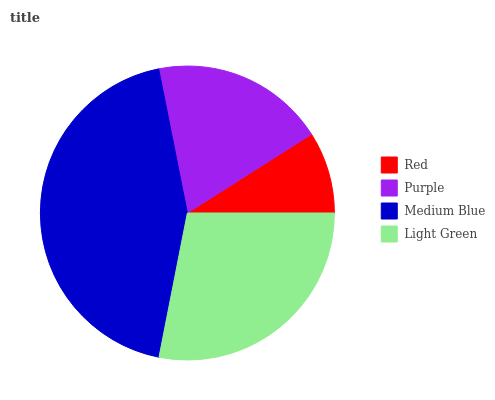Is Red the minimum?
Answer yes or no. Yes. Is Medium Blue the maximum?
Answer yes or no. Yes. Is Purple the minimum?
Answer yes or no. No. Is Purple the maximum?
Answer yes or no. No. Is Purple greater than Red?
Answer yes or no. Yes. Is Red less than Purple?
Answer yes or no. Yes. Is Red greater than Purple?
Answer yes or no. No. Is Purple less than Red?
Answer yes or no. No. Is Light Green the high median?
Answer yes or no. Yes. Is Purple the low median?
Answer yes or no. Yes. Is Purple the high median?
Answer yes or no. No. Is Light Green the low median?
Answer yes or no. No. 